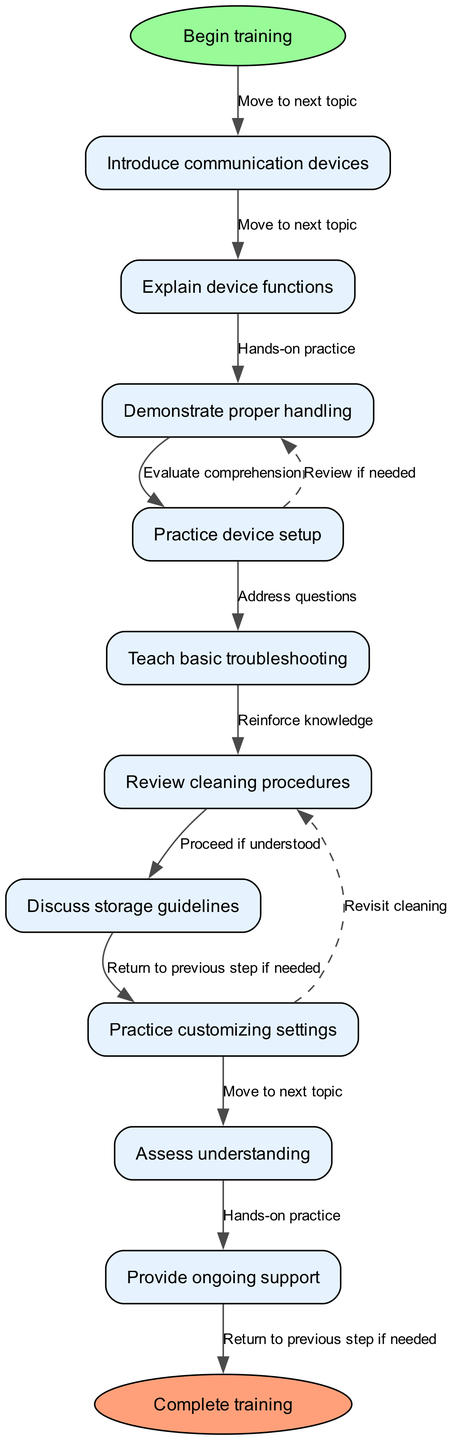What is the first node in the flowchart? The first node is directly linked to the "start" node and represents the initial step in the training process, which is "Introduce communication devices."
Answer: Introduce communication devices How many nodes are there in total? To find the total number of nodes, we counted the nodes from the beginning to the end of the flowchart. There are 9 training steps plus the start and end nodes, making a total of 11 nodes.
Answer: 11 What is the label of the last edge in the flowchart? The last edge connects the final training step, "Practice customizing settings," to the end node. The label of this edge is "Complete training."
Answer: Complete training What happens after "Practice device setup"? After "Practice device setup," the flowchart shows the next step as "Teach basic troubleshooting." This indicates a linear progression in the training process.
Answer: Teach basic troubleshooting What are the two nodes that have dashed edges connecting them? The dashed edges connect "Review cleaning procedures" and "Revisit cleaning." One edge connects "Practice device setup" to "Demonstrate proper handling," while another connects "Practice customizing settings" to "Teach basic troubleshooting."
Answer: Review cleaning procedures and Revisit cleaning Which node evaluates comprehension during the training? The node that evaluates comprehension is "Assess understanding," which follows the step of "Teach basic troubleshooting." This step is crucial in determining if the learners grasp the material.
Answer: Assess understanding What does the flowchart indicate follows "Explain device functions"? Following "Explain device functions," the flowchart indicates the next step is "Demonstrate proper handling." This represents a continuation of the training focus on practical application.
Answer: Demonstrate proper handling Why might "Practice customizing settings" lead back to "Teach basic troubleshooting"? "Practice customizing settings" may lead back to "Teach basic troubleshooting" if the user encounters issues during the customization process. This represents the need to revisit troubleshooting techniques.
Answer: Revisit troubleshooting techniques 